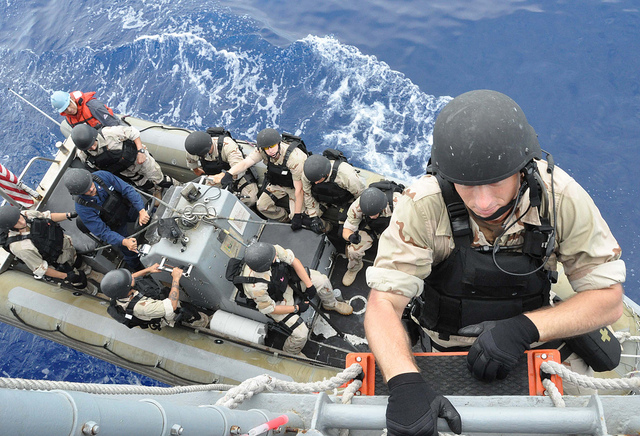<image>Are the men having a tea party? No, the men are not having a tea party. Are the men having a tea party? No, the men are not having a tea party. 